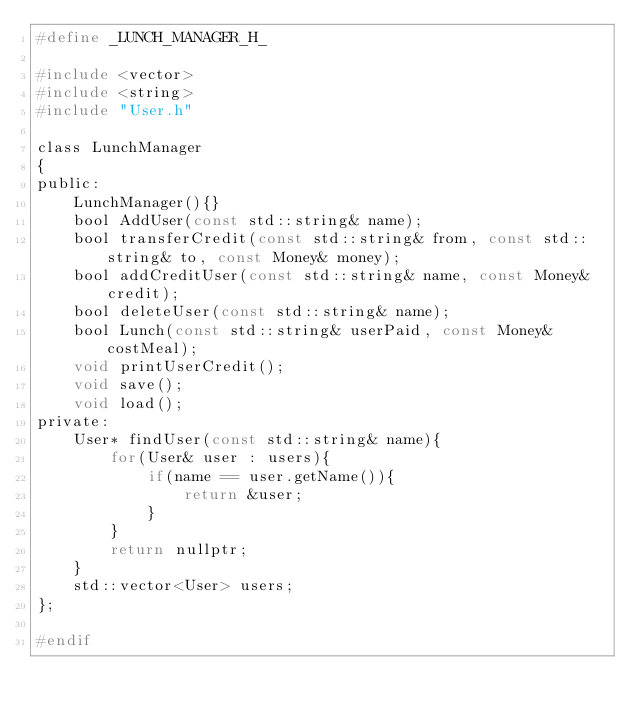<code> <loc_0><loc_0><loc_500><loc_500><_C_>#define _LUNCH_MANAGER_H_

#include <vector>
#include <string>
#include "User.h"

class LunchManager
{
public:
	LunchManager(){}
	bool AddUser(const std::string& name);
	bool transferCredit(const std::string& from, const std::string& to, const Money& money);
	bool addCreditUser(const std::string& name, const Money& credit);
	bool deleteUser(const std::string& name);
	bool Lunch(const std::string& userPaid, const Money& costMeal);
	void printUserCredit();
	void save();
	void load();
private:
	User* findUser(const std::string& name){
		for(User& user : users){
			if(name == user.getName()){
				return &user;
			}
		}
		return nullptr;
	}
	std::vector<User> users;
};

#endif
</code> 